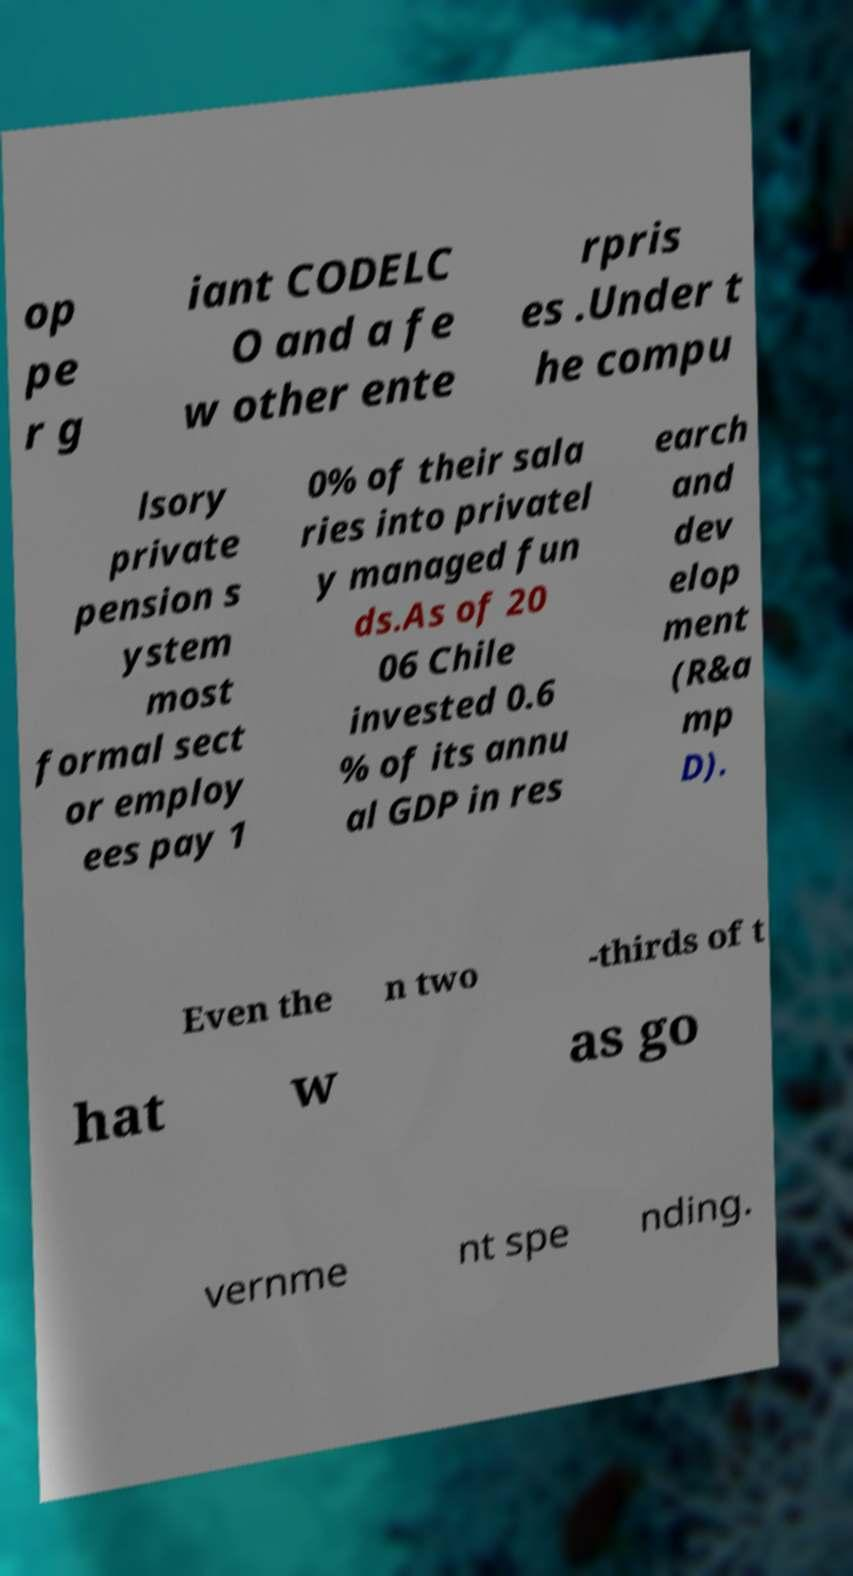For documentation purposes, I need the text within this image transcribed. Could you provide that? op pe r g iant CODELC O and a fe w other ente rpris es .Under t he compu lsory private pension s ystem most formal sect or employ ees pay 1 0% of their sala ries into privatel y managed fun ds.As of 20 06 Chile invested 0.6 % of its annu al GDP in res earch and dev elop ment (R&a mp D). Even the n two -thirds of t hat w as go vernme nt spe nding. 